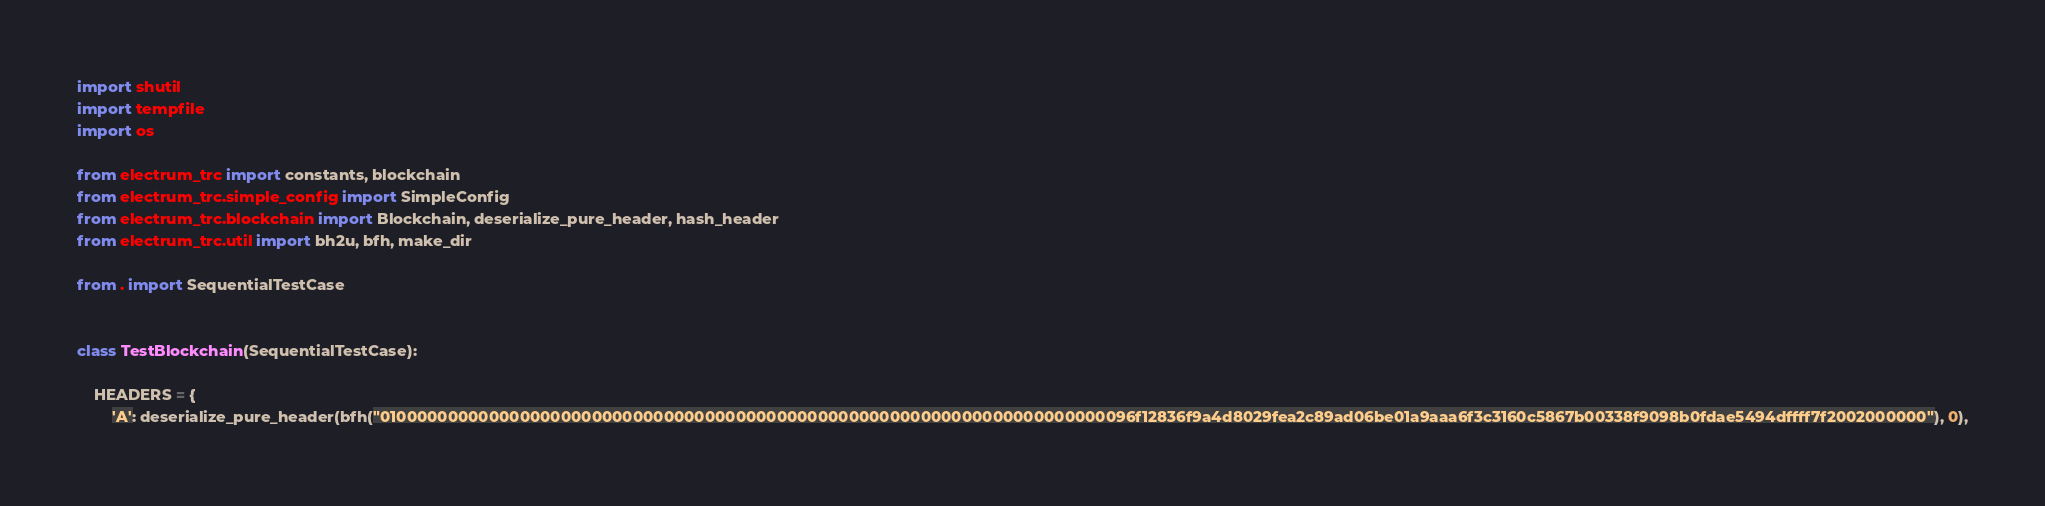Convert code to text. <code><loc_0><loc_0><loc_500><loc_500><_Python_>import shutil
import tempfile
import os

from electrum_trc import constants, blockchain
from electrum_trc.simple_config import SimpleConfig
from electrum_trc.blockchain import Blockchain, deserialize_pure_header, hash_header
from electrum_trc.util import bh2u, bfh, make_dir

from . import SequentialTestCase


class TestBlockchain(SequentialTestCase):

    HEADERS = {
        'A': deserialize_pure_header(bfh("01000000000000000000000000000000000000000000000000000000000000000000000096f12836f9a4d8029fea2c89ad06be01a9aaa6f3c3160c5867b00338f9098b0fdae5494dffff7f2002000000"), 0),</code> 